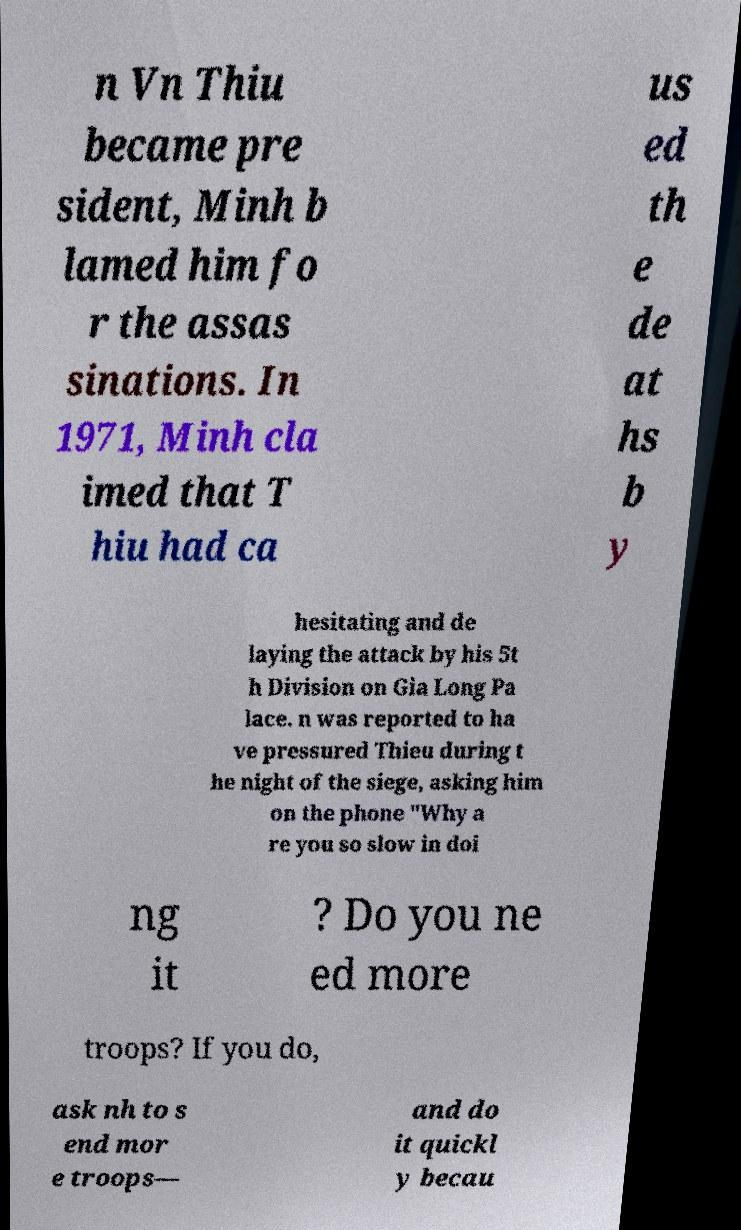Please identify and transcribe the text found in this image. n Vn Thiu became pre sident, Minh b lamed him fo r the assas sinations. In 1971, Minh cla imed that T hiu had ca us ed th e de at hs b y hesitating and de laying the attack by his 5t h Division on Gia Long Pa lace. n was reported to ha ve pressured Thieu during t he night of the siege, asking him on the phone "Why a re you so slow in doi ng it ? Do you ne ed more troops? If you do, ask nh to s end mor e troops— and do it quickl y becau 